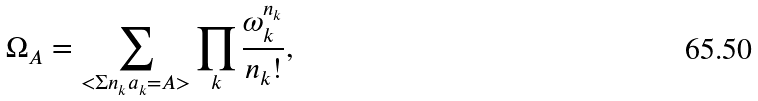<formula> <loc_0><loc_0><loc_500><loc_500>\Omega _ { A } = \sum _ { < \Sigma n _ { k } a _ { k } = A > } \prod _ { k } \frac { \omega _ { k } ^ { n _ { k } } } { n _ { k } ! } ,</formula> 